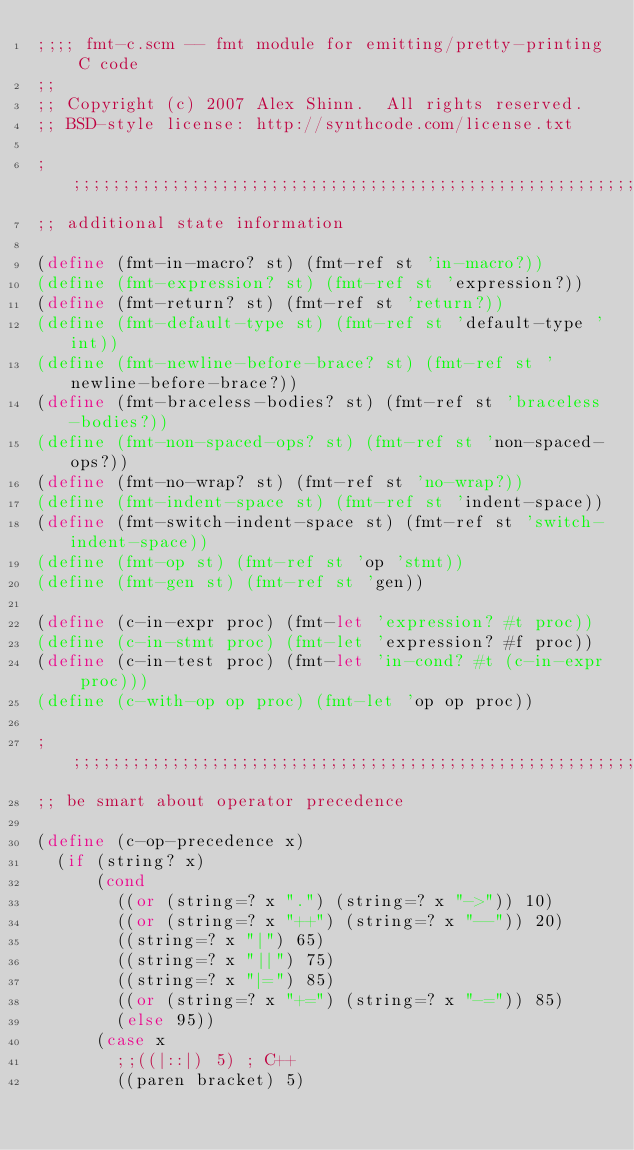Convert code to text. <code><loc_0><loc_0><loc_500><loc_500><_Scheme_>;;;; fmt-c.scm -- fmt module for emitting/pretty-printing C code
;;
;; Copyright (c) 2007 Alex Shinn.  All rights reserved.
;; BSD-style license: http://synthcode.com/license.txt

;;;;;;;;;;;;;;;;;;;;;;;;;;;;;;;;;;;;;;;;;;;;;;;;;;;;;;;;;;;;;;;;;;;;;;;;
;; additional state information

(define (fmt-in-macro? st) (fmt-ref st 'in-macro?))
(define (fmt-expression? st) (fmt-ref st 'expression?))
(define (fmt-return? st) (fmt-ref st 'return?))
(define (fmt-default-type st) (fmt-ref st 'default-type 'int))
(define (fmt-newline-before-brace? st) (fmt-ref st 'newline-before-brace?))
(define (fmt-braceless-bodies? st) (fmt-ref st 'braceless-bodies?))
(define (fmt-non-spaced-ops? st) (fmt-ref st 'non-spaced-ops?))
(define (fmt-no-wrap? st) (fmt-ref st 'no-wrap?))
(define (fmt-indent-space st) (fmt-ref st 'indent-space))
(define (fmt-switch-indent-space st) (fmt-ref st 'switch-indent-space))
(define (fmt-op st) (fmt-ref st 'op 'stmt))
(define (fmt-gen st) (fmt-ref st 'gen))

(define (c-in-expr proc) (fmt-let 'expression? #t proc))
(define (c-in-stmt proc) (fmt-let 'expression? #f proc))
(define (c-in-test proc) (fmt-let 'in-cond? #t (c-in-expr proc)))
(define (c-with-op op proc) (fmt-let 'op op proc))

;;;;;;;;;;;;;;;;;;;;;;;;;;;;;;;;;;;;;;;;;;;;;;;;;;;;;;;;;;;;;;;;;;;;;;;;
;; be smart about operator precedence

(define (c-op-precedence x)
  (if (string? x)
      (cond
        ((or (string=? x ".") (string=? x "->")) 10)
        ((or (string=? x "++") (string=? x "--")) 20)
        ((string=? x "|") 65)
        ((string=? x "||") 75)
        ((string=? x "|=") 85)
        ((or (string=? x "+=") (string=? x "-=")) 85)
        (else 95))
      (case x
        ;;((|::|) 5) ; C++
        ((paren bracket) 5)</code> 